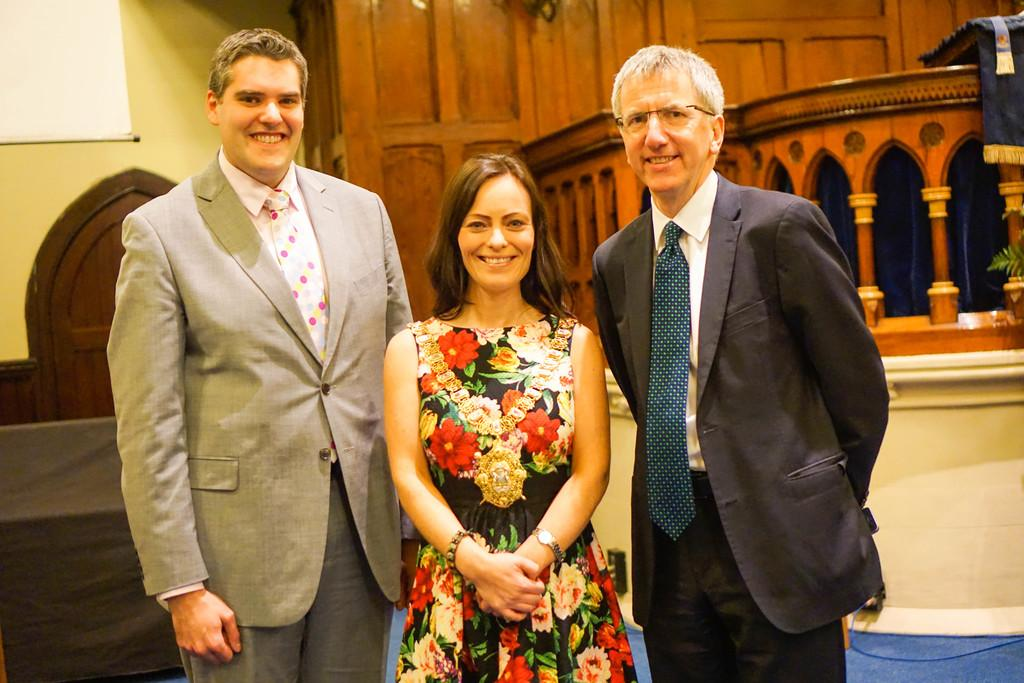How many people are in the image? There are two men and a woman in the image, making a total of three people. What are the individuals in the image doing? The individuals are standing in front and smiling. What can be seen in the background of the image? There is a wall and wooden objects in the background of the image. What type of house is visible in the image? There is no house visible in the image; only a wall and wooden objects can be seen in the background. What attempt is being made by the individuals in the image? There is no attempt being made by the individuals in the image; they are simply standing and smiling. 